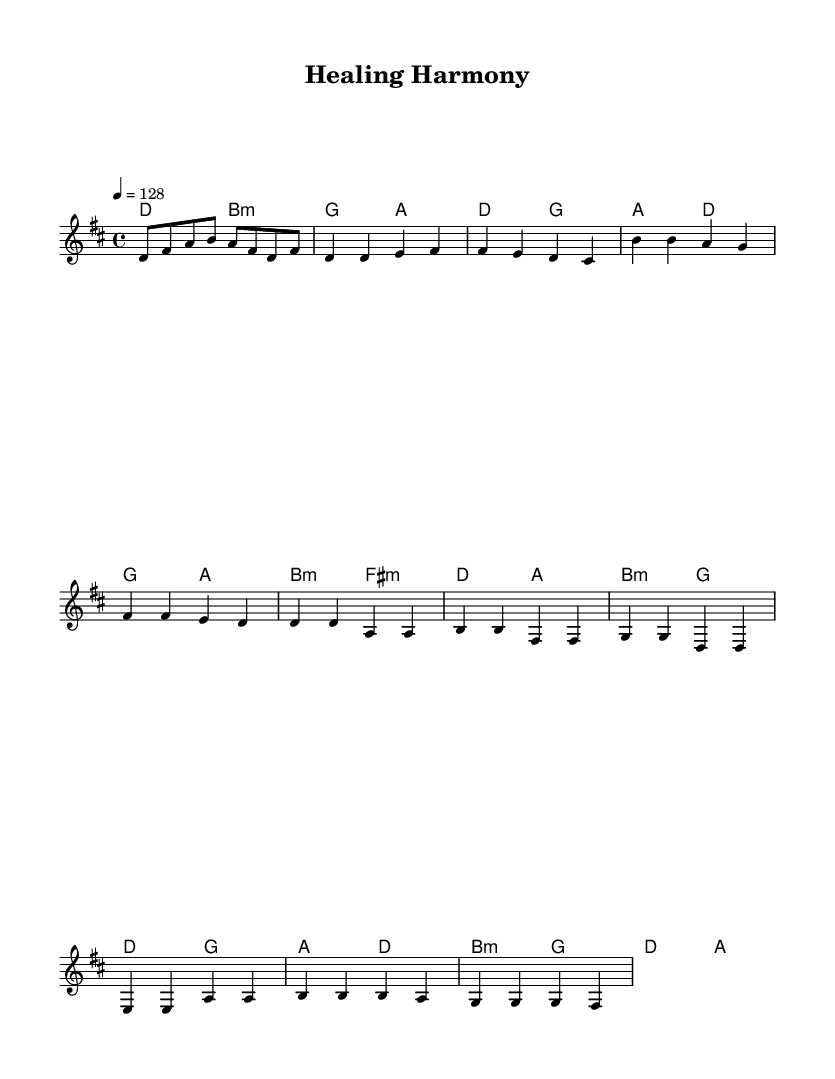What is the key signature of this music? The key signature is indicated as D major, which contains two sharps (F# and C#).
Answer: D major What is the time signature of the piece? The time signature shown in the music sheet is 4/4, meaning there are four beats in each measure and the quarter note gets one beat.
Answer: 4/4 What is the tempo marking for this piece? The tempo marking indicates that the piece should be played at a speed of 128 beats per minute.
Answer: 128 How many measures are in the chorus section of this piece? The chorus section is comprised of four measures, which can be counted by reviewing the measures in the score where chorus-specific notes are written.
Answer: 4 What type of chords are primarily used in the verse? The primary chords in the verse are major chords, specifically D and G major, which are foundational in establishing the key.
Answer: Major chords How does the bridge contrast with the rest of the song? The bridge features a change from the previous sections by primarily using minor chords and a different melodic contour, adding a contrasting emotional depth to the song.
Answer: Different emotional depth What traditional themes might this song incorporate based on its title "Healing Harmony"? Based on the title, it likely incorporates themes of traditional healing practices such as meditation, wellness, or holistic approaches intertwined with modern medical narratives.
Answer: Traditional healing practices 